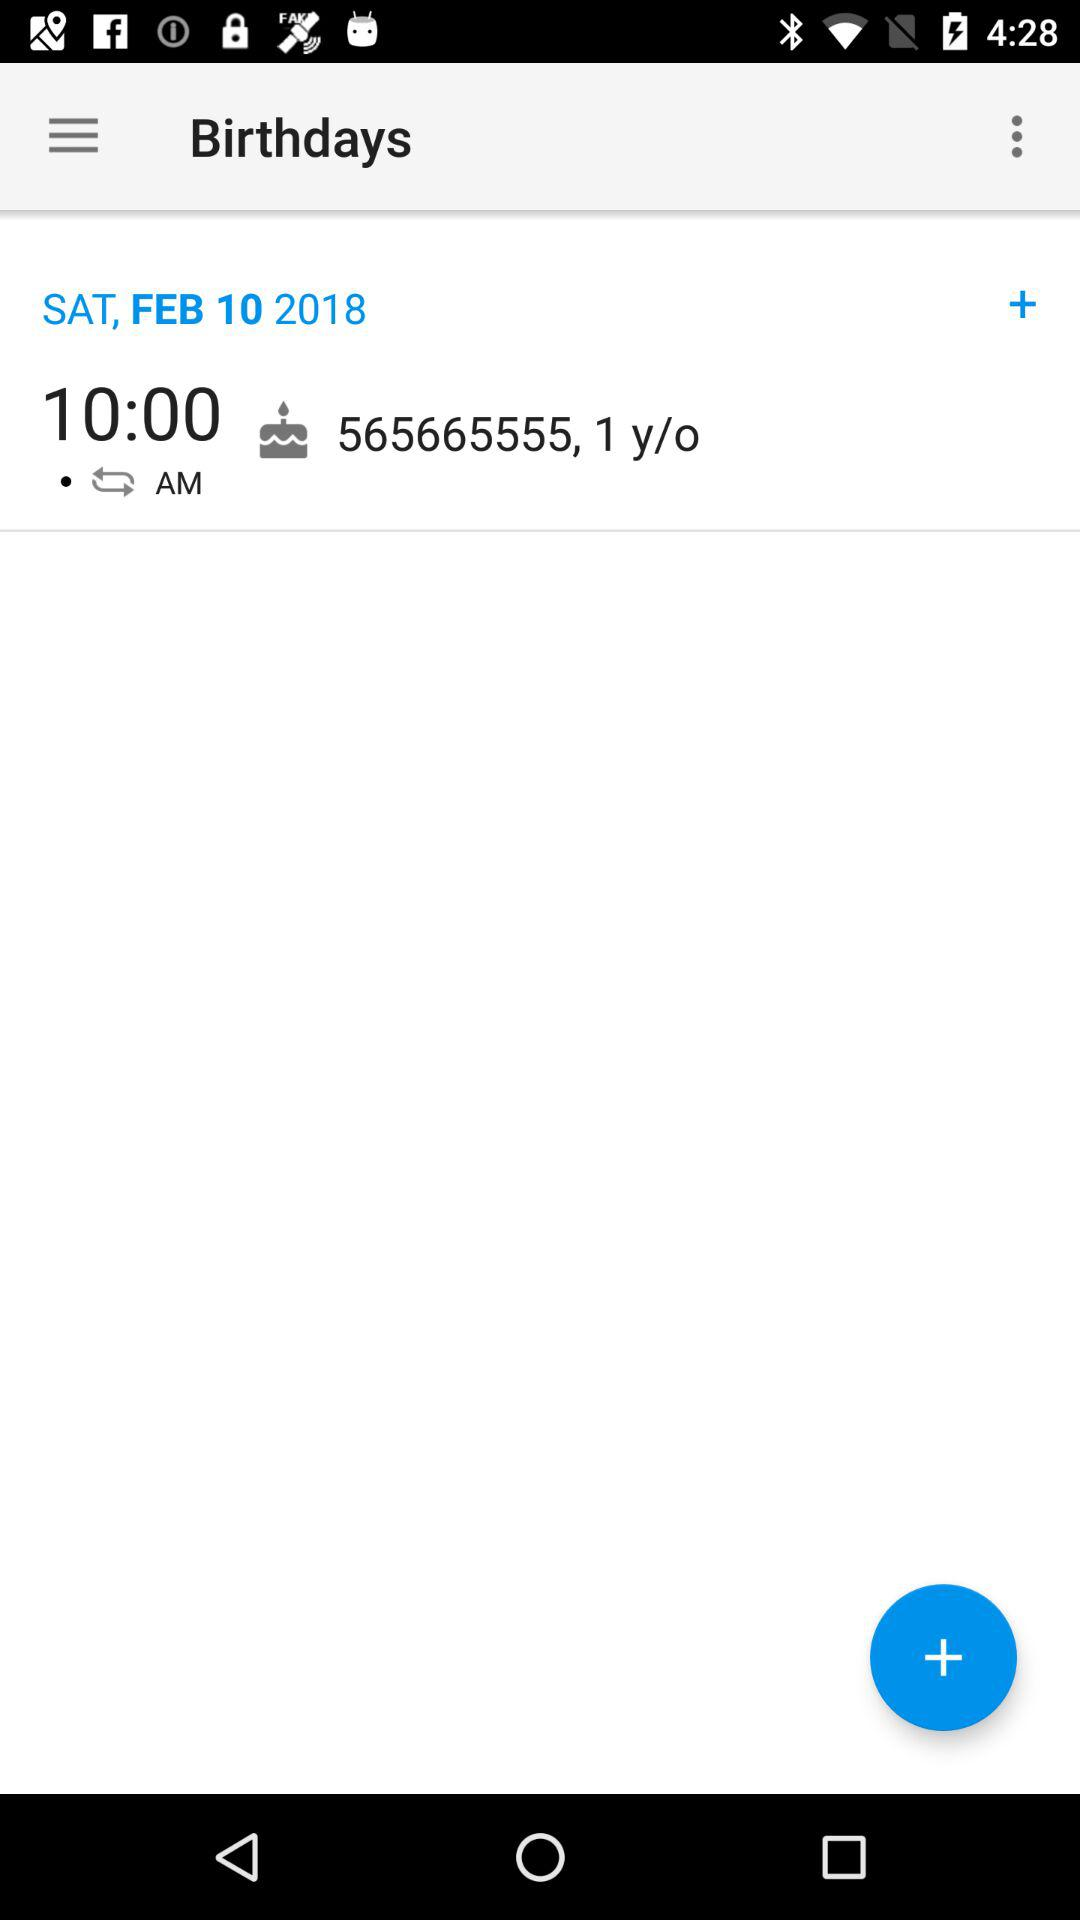For what date is the reminder set? The date is Saturday, February 10, 2018. 